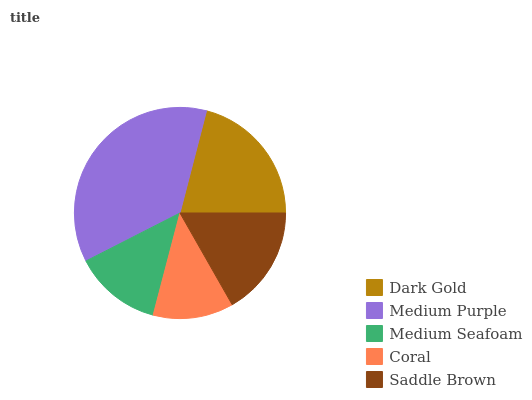Is Coral the minimum?
Answer yes or no. Yes. Is Medium Purple the maximum?
Answer yes or no. Yes. Is Medium Seafoam the minimum?
Answer yes or no. No. Is Medium Seafoam the maximum?
Answer yes or no. No. Is Medium Purple greater than Medium Seafoam?
Answer yes or no. Yes. Is Medium Seafoam less than Medium Purple?
Answer yes or no. Yes. Is Medium Seafoam greater than Medium Purple?
Answer yes or no. No. Is Medium Purple less than Medium Seafoam?
Answer yes or no. No. Is Saddle Brown the high median?
Answer yes or no. Yes. Is Saddle Brown the low median?
Answer yes or no. Yes. Is Medium Seafoam the high median?
Answer yes or no. No. Is Medium Seafoam the low median?
Answer yes or no. No. 